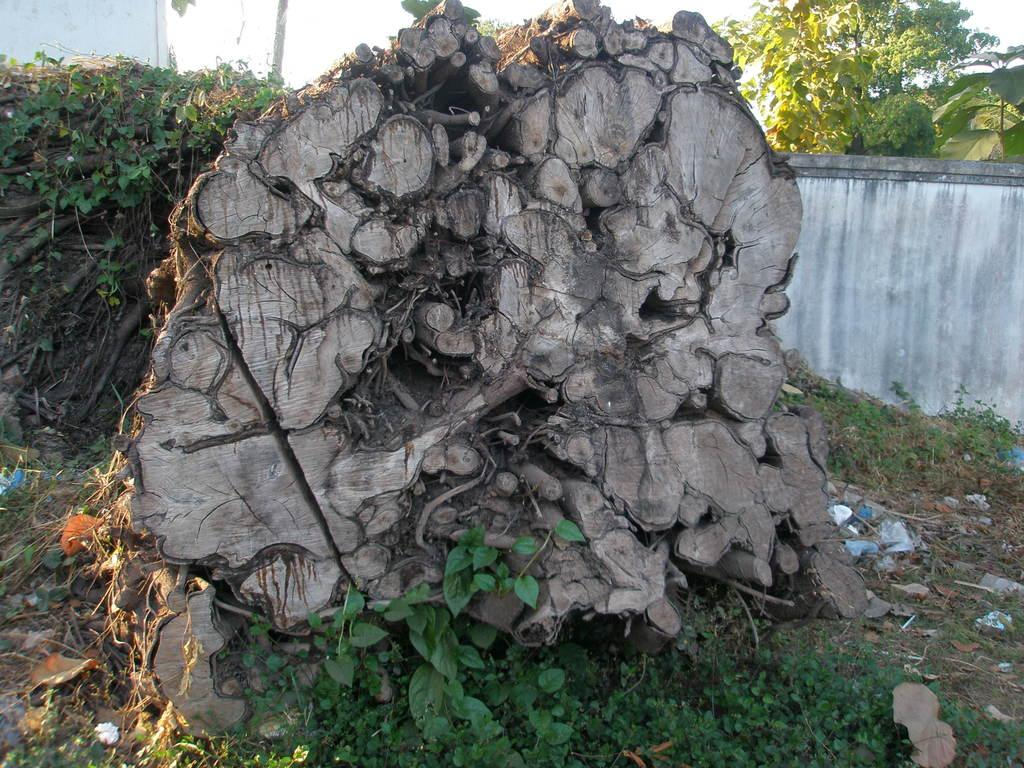What is located in the foreground of the image? In the foreground of the image, there is a tree trunk, grass, plants, creepers, and a fence. What type of vegetation can be seen in the foreground? In the foreground, there are plants and creepers visible. What is visible in the background of the image? In the background of the image, there are buildings, trees, and the sky. Can you describe the time of day the image was taken? The image is likely taken during the day, as the sky is visible and there is no indication of darkness. Can you tell me how many geese are standing on the writer's toe in the image? There is no writer or toe present in the image, and therefore no geese can be found standing on a writer's toe. 